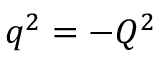Convert formula to latex. <formula><loc_0><loc_0><loc_500><loc_500>q ^ { 2 } = - Q ^ { 2 }</formula> 